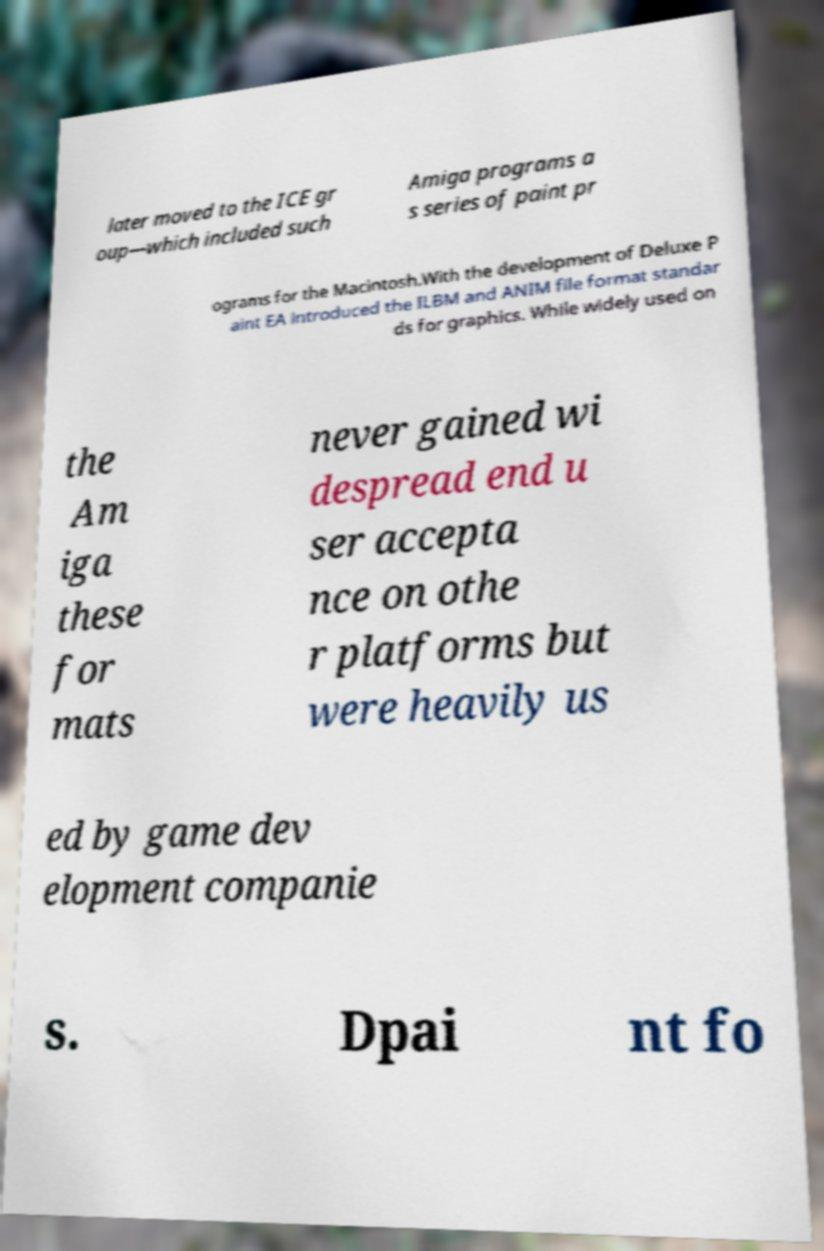Please read and relay the text visible in this image. What does it say? later moved to the ICE gr oup—which included such Amiga programs a s series of paint pr ograms for the Macintosh.With the development of Deluxe P aint EA introduced the ILBM and ANIM file format standar ds for graphics. While widely used on the Am iga these for mats never gained wi despread end u ser accepta nce on othe r platforms but were heavily us ed by game dev elopment companie s. Dpai nt fo 